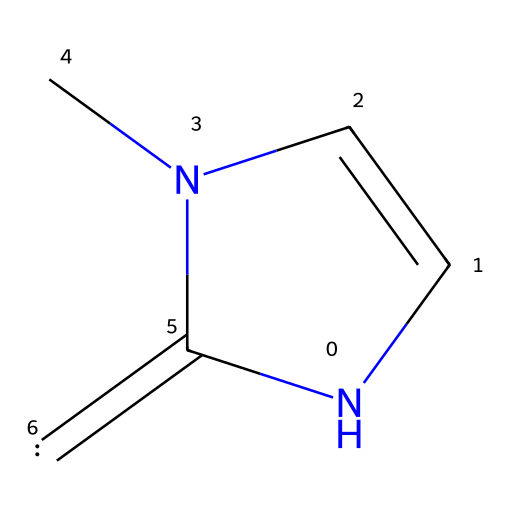What is the molecular formula of this compound? To deduce the molecular formula, we count the number of each type of atom present in the structure. The SMILES indicates two nitrogen (N) atoms, four carbon (C) atoms, and five hydrogen (H) atoms. Therefore, the molecular formula is C4H5N2.
Answer: C4H5N2 How many double bonds are present in this chemical? In the provided structure, we identify double bonds by looking for "=" signs in the SMILES notation. There are two instances of double bonds within the chemical, indicating a total of two double bonds.
Answer: 2 What functional group is present in this compound? By examining the structure, we observe the presence of a nitrogen atom connected to two carbon atoms and forming a double bond with another carbon atom, characteristic of nitrogen-containing cyclic structures. Thus, the functional group is classified as a N-heterocyclic carbene.
Answer: N-heterocyclic carbene What type of stabilization can N-heterocyclic carbenes provide during the synthesis of nanoparticles? N-heterocyclic carbenes can stabilize nanoparticles by acting as ligands, preventing aggregation and enhancing the uniformity of size and shape during synthesis.
Answer: Ligand stabilization What is one potential application of this compound in data storage? This compound may potentially stabilize nanoparticles that can be used in non-volatile memory systems or as components of data storage devices, which benefit from structured organization at the nanoscale.
Answer: Data storage components 